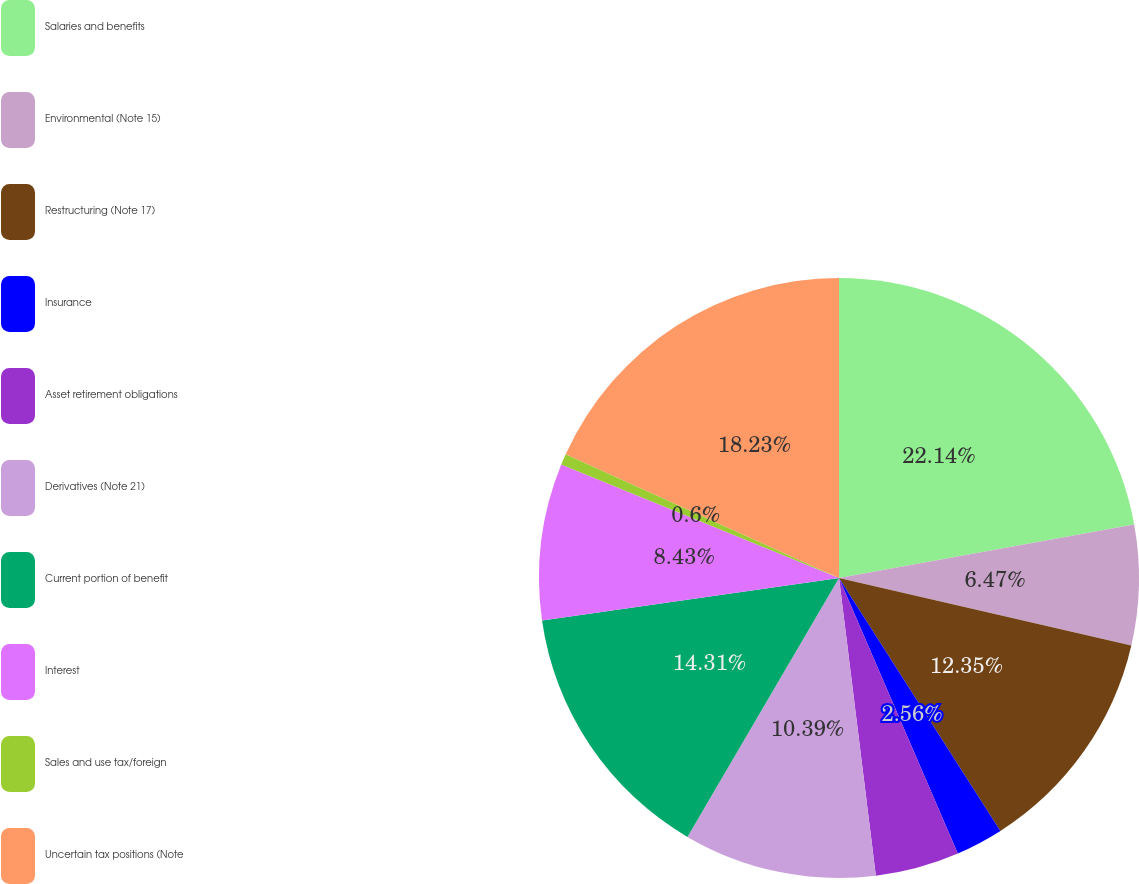<chart> <loc_0><loc_0><loc_500><loc_500><pie_chart><fcel>Salaries and benefits<fcel>Environmental (Note 15)<fcel>Restructuring (Note 17)<fcel>Insurance<fcel>Asset retirement obligations<fcel>Derivatives (Note 21)<fcel>Current portion of benefit<fcel>Interest<fcel>Sales and use tax/foreign<fcel>Uncertain tax positions (Note<nl><fcel>22.14%<fcel>6.47%<fcel>12.35%<fcel>2.56%<fcel>4.52%<fcel>10.39%<fcel>14.31%<fcel>8.43%<fcel>0.6%<fcel>18.23%<nl></chart> 